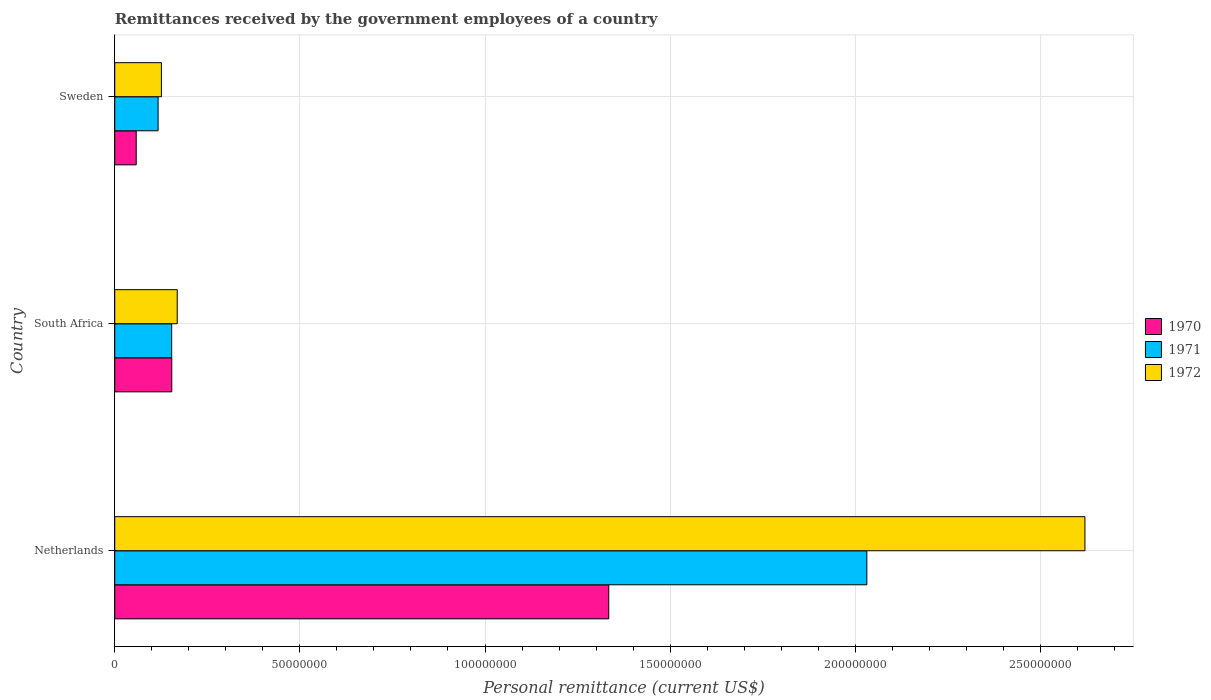How many different coloured bars are there?
Your answer should be very brief. 3. How many groups of bars are there?
Ensure brevity in your answer.  3. How many bars are there on the 3rd tick from the bottom?
Ensure brevity in your answer.  3. What is the label of the 3rd group of bars from the top?
Make the answer very short. Netherlands. What is the remittances received by the government employees in 1970 in Netherlands?
Offer a terse response. 1.33e+08. Across all countries, what is the maximum remittances received by the government employees in 1970?
Your answer should be very brief. 1.33e+08. Across all countries, what is the minimum remittances received by the government employees in 1971?
Make the answer very short. 1.17e+07. In which country was the remittances received by the government employees in 1971 maximum?
Make the answer very short. Netherlands. What is the total remittances received by the government employees in 1971 in the graph?
Offer a very short reply. 2.30e+08. What is the difference between the remittances received by the government employees in 1971 in Netherlands and that in South Africa?
Your answer should be very brief. 1.88e+08. What is the difference between the remittances received by the government employees in 1971 in Netherlands and the remittances received by the government employees in 1970 in South Africa?
Ensure brevity in your answer.  1.88e+08. What is the average remittances received by the government employees in 1971 per country?
Your response must be concise. 7.67e+07. What is the difference between the remittances received by the government employees in 1971 and remittances received by the government employees in 1972 in South Africa?
Keep it short and to the point. -1.49e+06. What is the ratio of the remittances received by the government employees in 1971 in Netherlands to that in South Africa?
Your answer should be very brief. 13.21. Is the remittances received by the government employees in 1970 in Netherlands less than that in South Africa?
Ensure brevity in your answer.  No. What is the difference between the highest and the second highest remittances received by the government employees in 1970?
Ensure brevity in your answer.  1.18e+08. What is the difference between the highest and the lowest remittances received by the government employees in 1972?
Your answer should be compact. 2.49e+08. Is the sum of the remittances received by the government employees in 1971 in Netherlands and South Africa greater than the maximum remittances received by the government employees in 1972 across all countries?
Ensure brevity in your answer.  No. Where does the legend appear in the graph?
Your answer should be very brief. Center right. How many legend labels are there?
Make the answer very short. 3. How are the legend labels stacked?
Your answer should be compact. Vertical. What is the title of the graph?
Ensure brevity in your answer.  Remittances received by the government employees of a country. Does "1963" appear as one of the legend labels in the graph?
Keep it short and to the point. No. What is the label or title of the X-axis?
Provide a short and direct response. Personal remittance (current US$). What is the label or title of the Y-axis?
Offer a very short reply. Country. What is the Personal remittance (current US$) in 1970 in Netherlands?
Provide a succinct answer. 1.33e+08. What is the Personal remittance (current US$) of 1971 in Netherlands?
Ensure brevity in your answer.  2.03e+08. What is the Personal remittance (current US$) of 1972 in Netherlands?
Keep it short and to the point. 2.62e+08. What is the Personal remittance (current US$) in 1970 in South Africa?
Offer a terse response. 1.54e+07. What is the Personal remittance (current US$) of 1971 in South Africa?
Your answer should be compact. 1.54e+07. What is the Personal remittance (current US$) of 1972 in South Africa?
Provide a succinct answer. 1.69e+07. What is the Personal remittance (current US$) of 1970 in Sweden?
Your response must be concise. 5.80e+06. What is the Personal remittance (current US$) of 1971 in Sweden?
Offer a terse response. 1.17e+07. What is the Personal remittance (current US$) of 1972 in Sweden?
Keep it short and to the point. 1.26e+07. Across all countries, what is the maximum Personal remittance (current US$) of 1970?
Provide a succinct answer. 1.33e+08. Across all countries, what is the maximum Personal remittance (current US$) of 1971?
Ensure brevity in your answer.  2.03e+08. Across all countries, what is the maximum Personal remittance (current US$) of 1972?
Ensure brevity in your answer.  2.62e+08. Across all countries, what is the minimum Personal remittance (current US$) in 1970?
Provide a short and direct response. 5.80e+06. Across all countries, what is the minimum Personal remittance (current US$) of 1971?
Your response must be concise. 1.17e+07. Across all countries, what is the minimum Personal remittance (current US$) of 1972?
Offer a very short reply. 1.26e+07. What is the total Personal remittance (current US$) in 1970 in the graph?
Your answer should be compact. 1.55e+08. What is the total Personal remittance (current US$) of 1971 in the graph?
Offer a terse response. 2.30e+08. What is the total Personal remittance (current US$) of 1972 in the graph?
Provide a short and direct response. 2.92e+08. What is the difference between the Personal remittance (current US$) of 1970 in Netherlands and that in South Africa?
Ensure brevity in your answer.  1.18e+08. What is the difference between the Personal remittance (current US$) of 1971 in Netherlands and that in South Africa?
Make the answer very short. 1.88e+08. What is the difference between the Personal remittance (current US$) of 1972 in Netherlands and that in South Africa?
Offer a terse response. 2.45e+08. What is the difference between the Personal remittance (current US$) in 1970 in Netherlands and that in Sweden?
Your answer should be very brief. 1.28e+08. What is the difference between the Personal remittance (current US$) of 1971 in Netherlands and that in Sweden?
Make the answer very short. 1.91e+08. What is the difference between the Personal remittance (current US$) of 1972 in Netherlands and that in Sweden?
Provide a succinct answer. 2.49e+08. What is the difference between the Personal remittance (current US$) in 1970 in South Africa and that in Sweden?
Provide a succinct answer. 9.60e+06. What is the difference between the Personal remittance (current US$) of 1971 in South Africa and that in Sweden?
Give a very brief answer. 3.67e+06. What is the difference between the Personal remittance (current US$) in 1972 in South Africa and that in Sweden?
Your answer should be compact. 4.27e+06. What is the difference between the Personal remittance (current US$) in 1970 in Netherlands and the Personal remittance (current US$) in 1971 in South Africa?
Offer a terse response. 1.18e+08. What is the difference between the Personal remittance (current US$) in 1970 in Netherlands and the Personal remittance (current US$) in 1972 in South Africa?
Ensure brevity in your answer.  1.17e+08. What is the difference between the Personal remittance (current US$) of 1971 in Netherlands and the Personal remittance (current US$) of 1972 in South Africa?
Keep it short and to the point. 1.86e+08. What is the difference between the Personal remittance (current US$) of 1970 in Netherlands and the Personal remittance (current US$) of 1971 in Sweden?
Offer a terse response. 1.22e+08. What is the difference between the Personal remittance (current US$) in 1970 in Netherlands and the Personal remittance (current US$) in 1972 in Sweden?
Ensure brevity in your answer.  1.21e+08. What is the difference between the Personal remittance (current US$) of 1971 in Netherlands and the Personal remittance (current US$) of 1972 in Sweden?
Offer a terse response. 1.91e+08. What is the difference between the Personal remittance (current US$) in 1970 in South Africa and the Personal remittance (current US$) in 1971 in Sweden?
Make the answer very short. 3.69e+06. What is the difference between the Personal remittance (current US$) of 1970 in South Africa and the Personal remittance (current US$) of 1972 in Sweden?
Give a very brief answer. 2.80e+06. What is the difference between the Personal remittance (current US$) of 1971 in South Africa and the Personal remittance (current US$) of 1972 in Sweden?
Give a very brief answer. 2.78e+06. What is the average Personal remittance (current US$) of 1970 per country?
Make the answer very short. 5.15e+07. What is the average Personal remittance (current US$) in 1971 per country?
Your answer should be compact. 7.67e+07. What is the average Personal remittance (current US$) in 1972 per country?
Ensure brevity in your answer.  9.72e+07. What is the difference between the Personal remittance (current US$) of 1970 and Personal remittance (current US$) of 1971 in Netherlands?
Give a very brief answer. -6.97e+07. What is the difference between the Personal remittance (current US$) of 1970 and Personal remittance (current US$) of 1972 in Netherlands?
Provide a short and direct response. -1.29e+08. What is the difference between the Personal remittance (current US$) in 1971 and Personal remittance (current US$) in 1972 in Netherlands?
Your answer should be very brief. -5.89e+07. What is the difference between the Personal remittance (current US$) of 1970 and Personal remittance (current US$) of 1971 in South Africa?
Your answer should be very brief. 2.18e+04. What is the difference between the Personal remittance (current US$) of 1970 and Personal remittance (current US$) of 1972 in South Africa?
Give a very brief answer. -1.47e+06. What is the difference between the Personal remittance (current US$) in 1971 and Personal remittance (current US$) in 1972 in South Africa?
Your answer should be compact. -1.49e+06. What is the difference between the Personal remittance (current US$) of 1970 and Personal remittance (current US$) of 1971 in Sweden?
Make the answer very short. -5.91e+06. What is the difference between the Personal remittance (current US$) of 1970 and Personal remittance (current US$) of 1972 in Sweden?
Offer a terse response. -6.80e+06. What is the difference between the Personal remittance (current US$) of 1971 and Personal remittance (current US$) of 1972 in Sweden?
Your answer should be compact. -8.93e+05. What is the ratio of the Personal remittance (current US$) of 1970 in Netherlands to that in South Africa?
Your answer should be compact. 8.66. What is the ratio of the Personal remittance (current US$) in 1971 in Netherlands to that in South Africa?
Provide a short and direct response. 13.21. What is the ratio of the Personal remittance (current US$) in 1972 in Netherlands to that in South Africa?
Offer a terse response. 15.53. What is the ratio of the Personal remittance (current US$) in 1970 in Netherlands to that in Sweden?
Give a very brief answer. 23.01. What is the ratio of the Personal remittance (current US$) of 1971 in Netherlands to that in Sweden?
Offer a very short reply. 17.35. What is the ratio of the Personal remittance (current US$) in 1972 in Netherlands to that in Sweden?
Your answer should be compact. 20.8. What is the ratio of the Personal remittance (current US$) in 1970 in South Africa to that in Sweden?
Make the answer very short. 2.66. What is the ratio of the Personal remittance (current US$) in 1971 in South Africa to that in Sweden?
Make the answer very short. 1.31. What is the ratio of the Personal remittance (current US$) in 1972 in South Africa to that in Sweden?
Your answer should be compact. 1.34. What is the difference between the highest and the second highest Personal remittance (current US$) of 1970?
Make the answer very short. 1.18e+08. What is the difference between the highest and the second highest Personal remittance (current US$) of 1971?
Your response must be concise. 1.88e+08. What is the difference between the highest and the second highest Personal remittance (current US$) in 1972?
Make the answer very short. 2.45e+08. What is the difference between the highest and the lowest Personal remittance (current US$) of 1970?
Your answer should be compact. 1.28e+08. What is the difference between the highest and the lowest Personal remittance (current US$) of 1971?
Provide a succinct answer. 1.91e+08. What is the difference between the highest and the lowest Personal remittance (current US$) in 1972?
Offer a very short reply. 2.49e+08. 